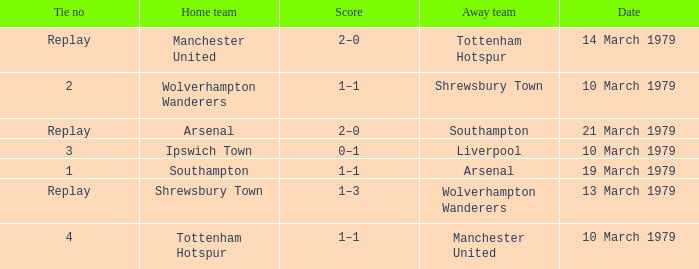What was the score for the tie that had Shrewsbury Town as home team? 1–3. 